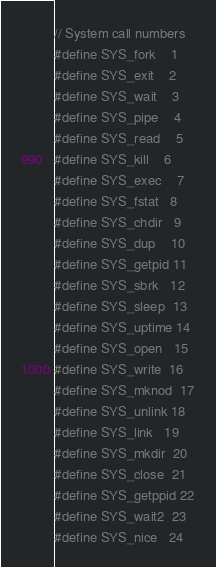Convert code to text. <code><loc_0><loc_0><loc_500><loc_500><_C_>// System call numbers
#define SYS_fork    1
#define SYS_exit    2
#define SYS_wait    3
#define SYS_pipe    4
#define SYS_read    5
#define SYS_kill    6
#define SYS_exec    7
#define SYS_fstat   8
#define SYS_chdir   9
#define SYS_dup    10
#define SYS_getpid 11
#define SYS_sbrk   12
#define SYS_sleep  13
#define SYS_uptime 14
#define SYS_open   15
#define SYS_write  16
#define SYS_mknod  17
#define SYS_unlink 18
#define SYS_link   19
#define SYS_mkdir  20
#define SYS_close  21
#define SYS_getppid 22
#define SYS_wait2  23
#define SYS_nice   24
</code> 